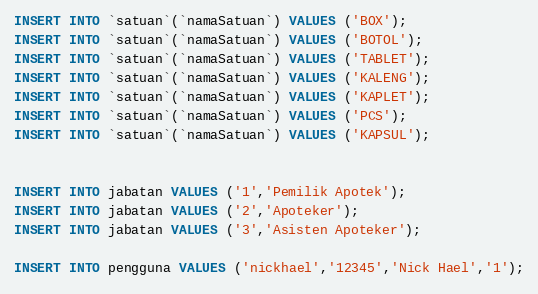<code> <loc_0><loc_0><loc_500><loc_500><_SQL_>INSERT INTO `satuan`(`namaSatuan`) VALUES ('BOX');
INSERT INTO `satuan`(`namaSatuan`) VALUES ('BOTOL');
INSERT INTO `satuan`(`namaSatuan`) VALUES ('TABLET');
INSERT INTO `satuan`(`namaSatuan`) VALUES ('KALENG');
INSERT INTO `satuan`(`namaSatuan`) VALUES ('KAPLET');
INSERT INTO `satuan`(`namaSatuan`) VALUES ('PCS');
INSERT INTO `satuan`(`namaSatuan`) VALUES ('KAPSUL');


INSERT INTO jabatan VALUES ('1','Pemilik Apotek');
INSERT INTO jabatan VALUES ('2','Apoteker');
INSERT INTO jabatan VALUES ('3','Asisten Apoteker');

INSERT INTO pengguna VALUES ('nickhael','12345','Nick Hael','1');</code> 